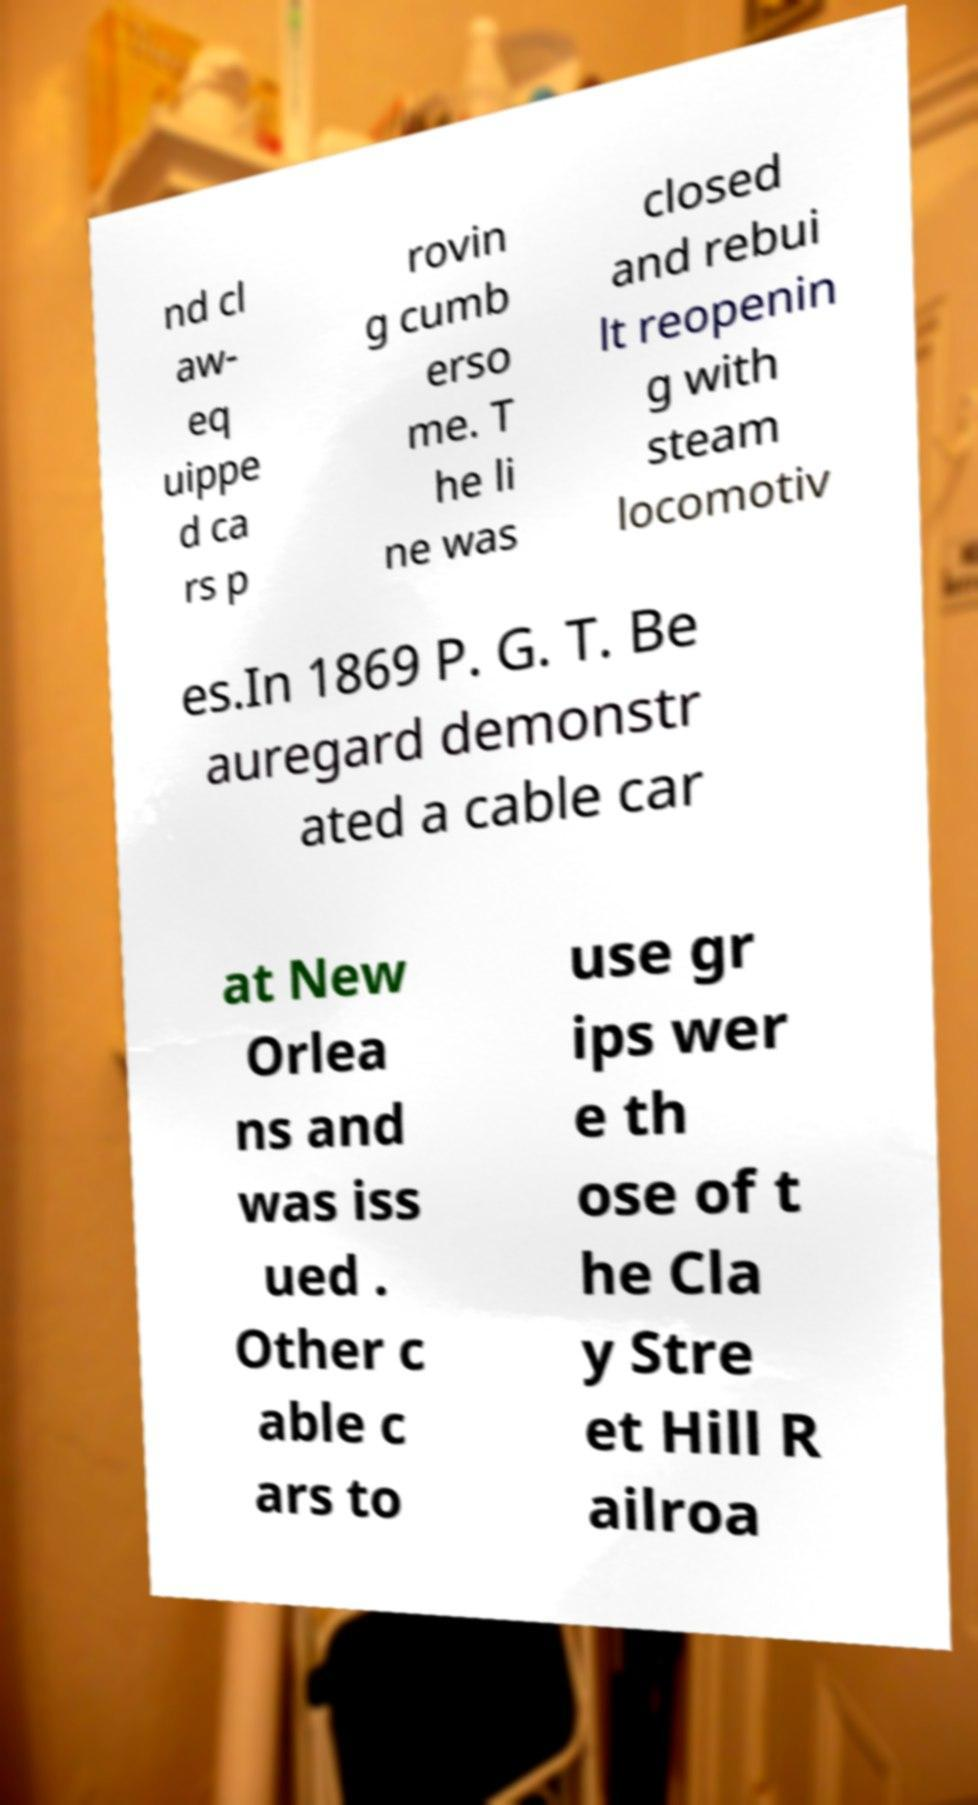Can you read and provide the text displayed in the image?This photo seems to have some interesting text. Can you extract and type it out for me? nd cl aw- eq uippe d ca rs p rovin g cumb erso me. T he li ne was closed and rebui lt reopenin g with steam locomotiv es.In 1869 P. G. T. Be auregard demonstr ated a cable car at New Orlea ns and was iss ued . Other c able c ars to use gr ips wer e th ose of t he Cla y Stre et Hill R ailroa 